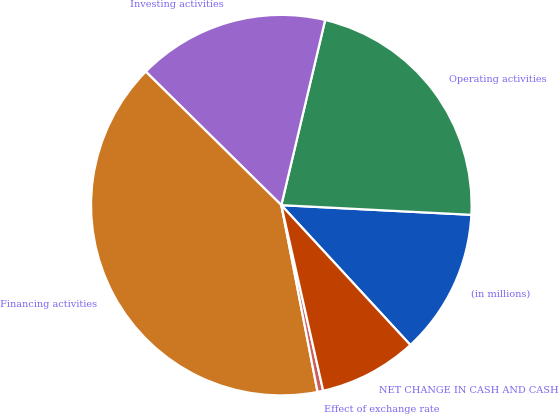<chart> <loc_0><loc_0><loc_500><loc_500><pie_chart><fcel>(in millions)<fcel>Operating activities<fcel>Investing activities<fcel>Financing activities<fcel>Effect of exchange rate<fcel>NET CHANGE IN CASH AND CASH<nl><fcel>12.33%<fcel>22.11%<fcel>16.32%<fcel>40.43%<fcel>0.48%<fcel>8.33%<nl></chart> 